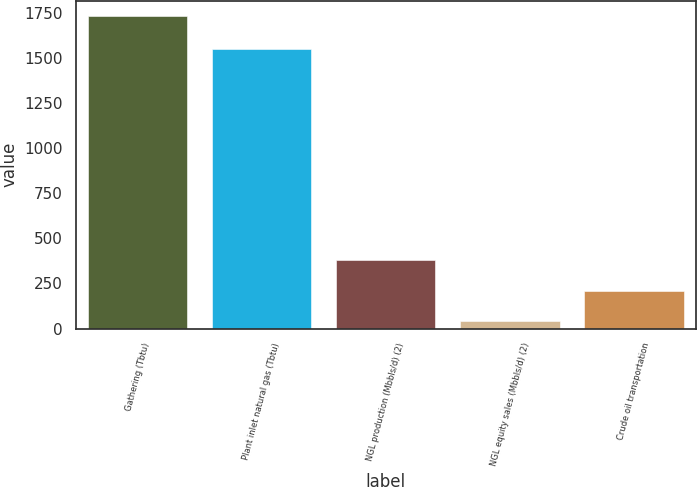Convert chart. <chart><loc_0><loc_0><loc_500><loc_500><bar_chart><fcel>Gathering (Tbtu)<fcel>Plant inlet natural gas (Tbtu)<fcel>NGL production (Mbbls/d) (2)<fcel>NGL equity sales (Mbbls/d) (2)<fcel>Crude oil transportation<nl><fcel>1731<fcel>1549<fcel>378.2<fcel>40<fcel>209.1<nl></chart> 